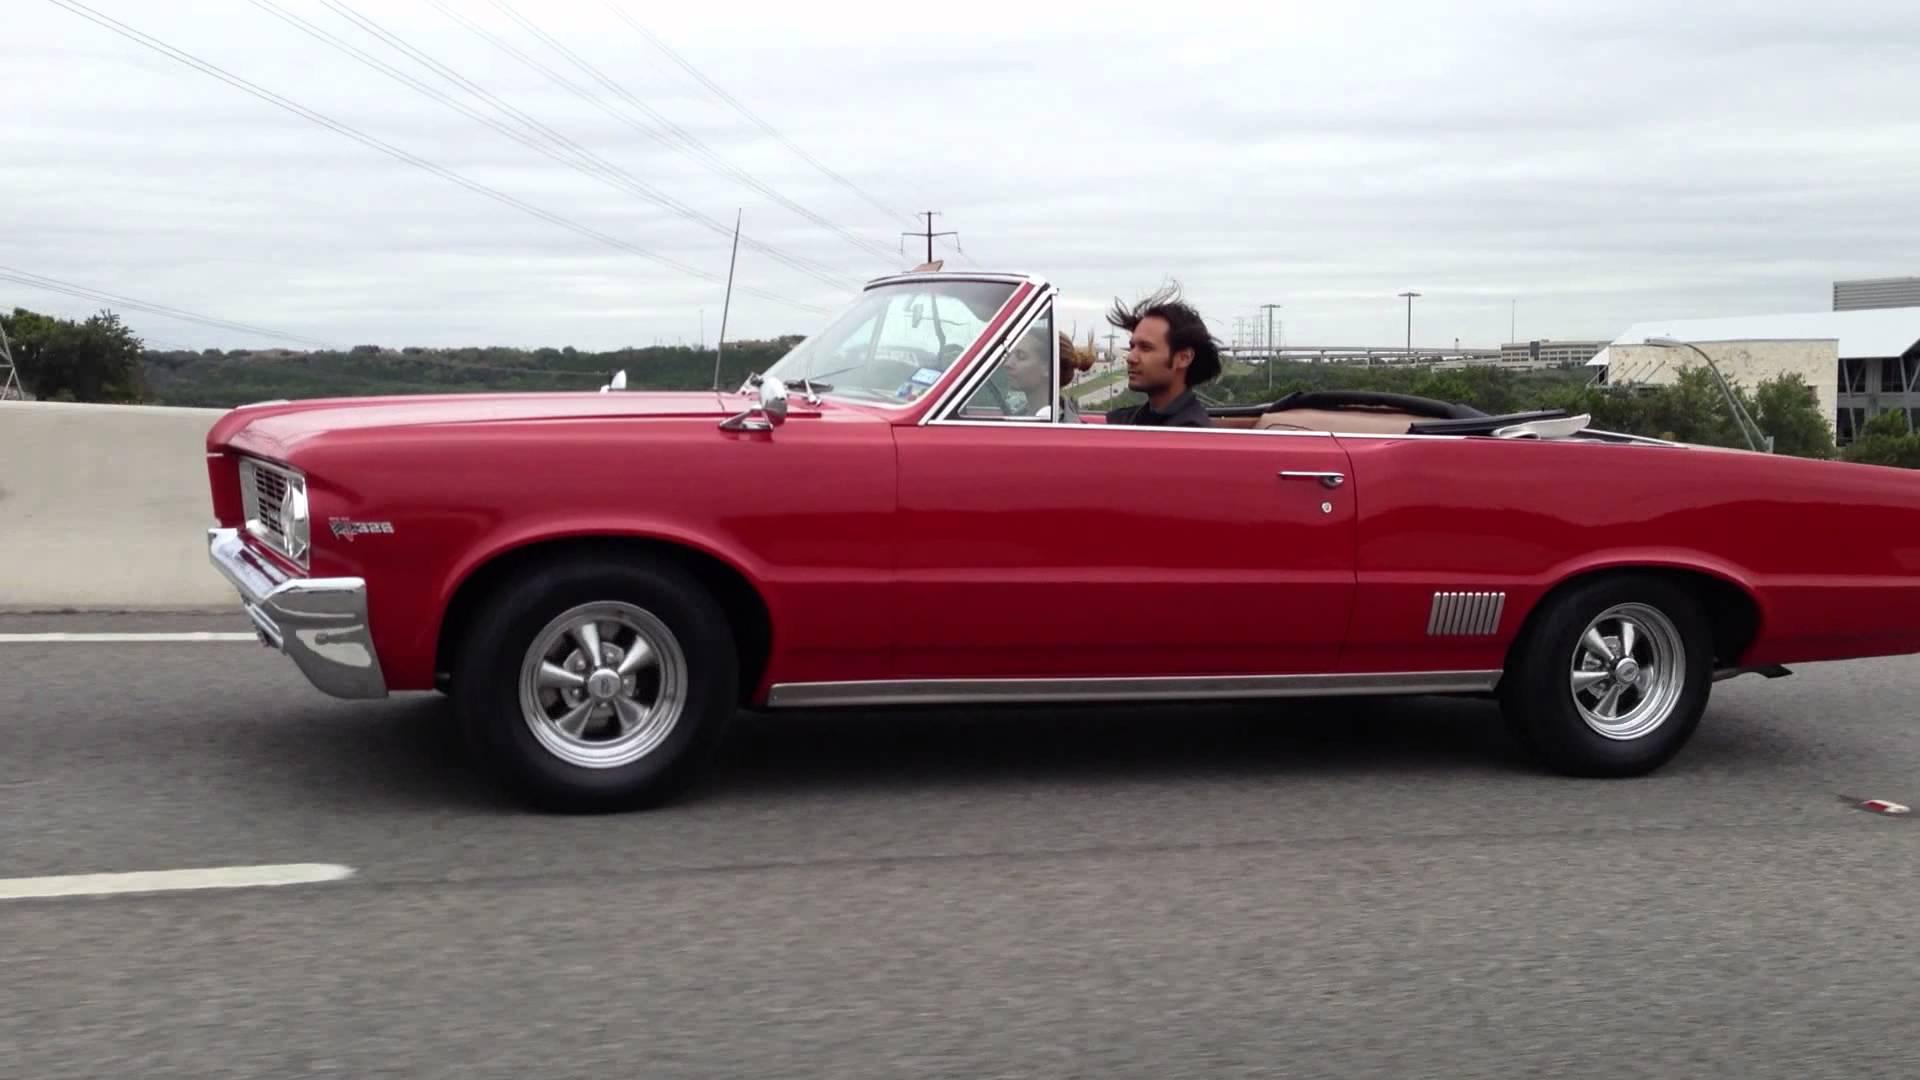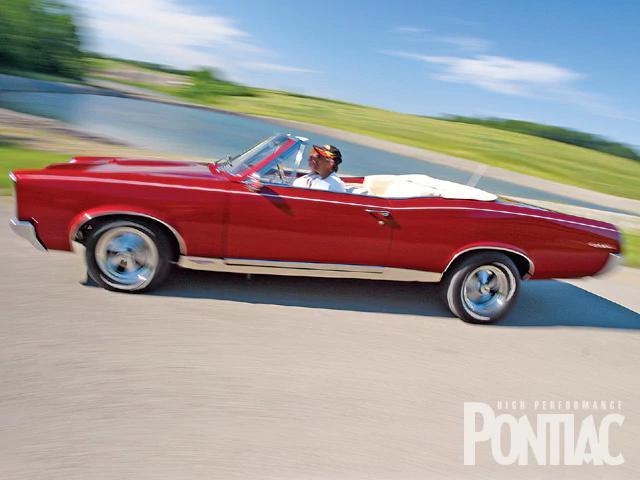The first image is the image on the left, the second image is the image on the right. For the images shown, is this caption "At least one vehicle is not red or pink." true? Answer yes or no. No. 